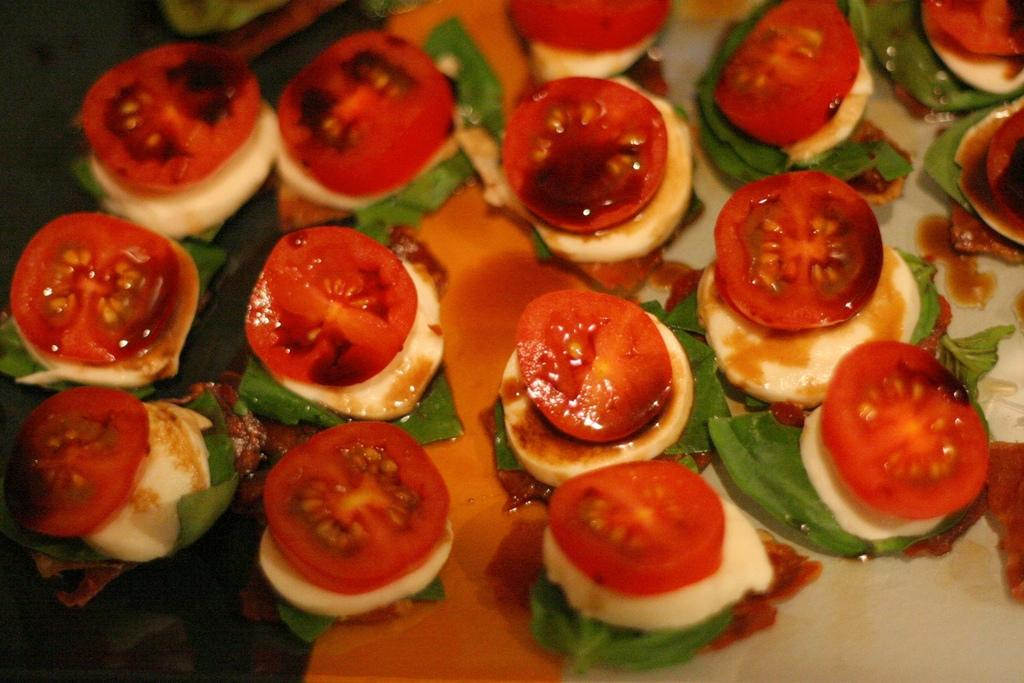What object is present on the plate in the image? There is a food item on the plate in the image. Can you describe the food item on the plate? The food item includes slices of tomato. What else can be seen in the image besides the plate and food item? There are leaves present in the image. What type of toy can be seen sailing on the plate in the image? There is no toy present in the image, and the plate does not depict a sailing scene. 